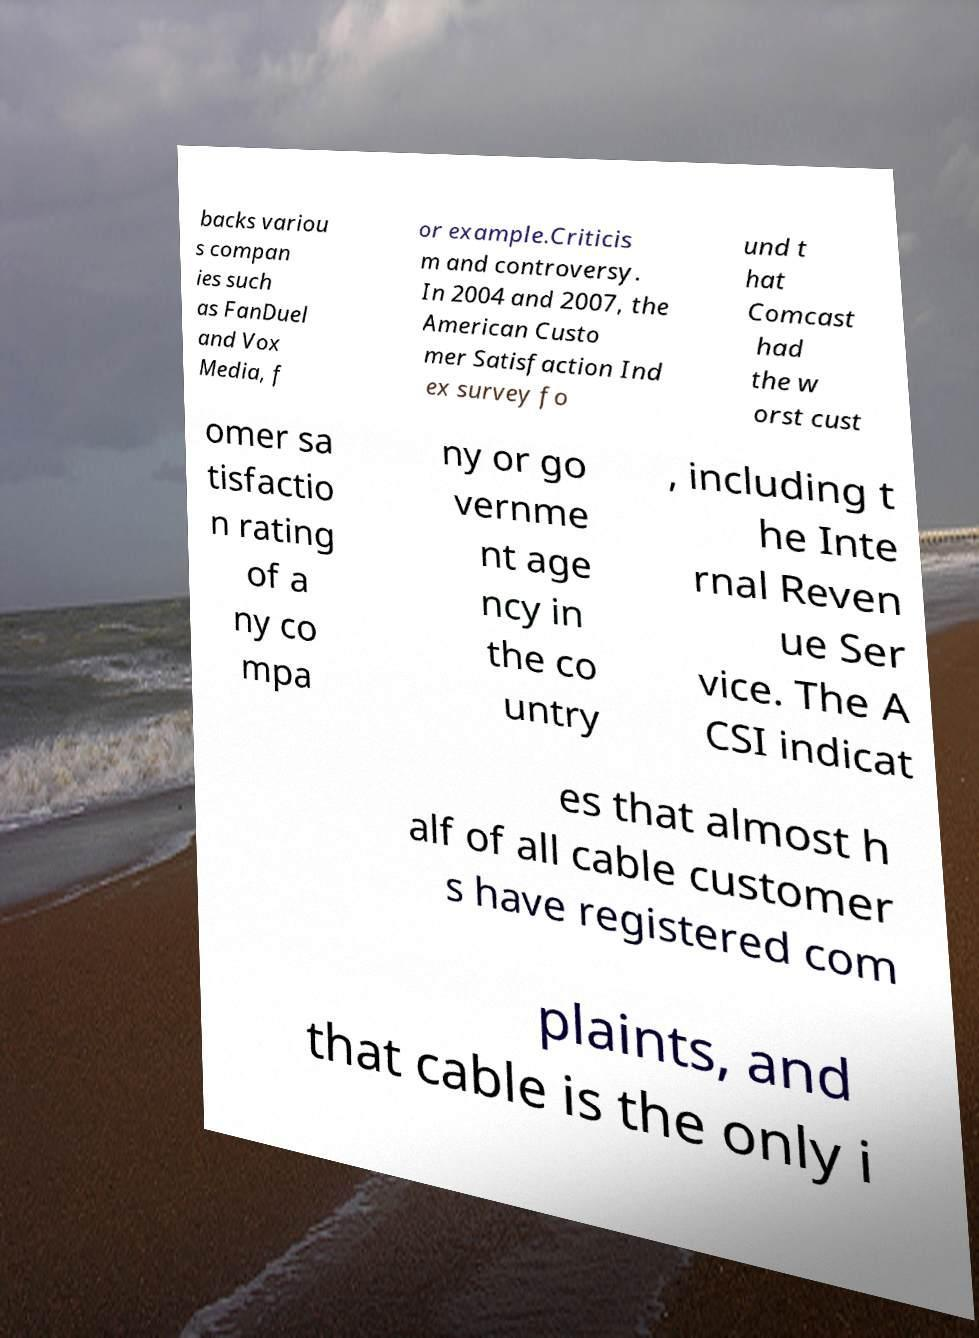Could you extract and type out the text from this image? backs variou s compan ies such as FanDuel and Vox Media, f or example.Criticis m and controversy. In 2004 and 2007, the American Custo mer Satisfaction Ind ex survey fo und t hat Comcast had the w orst cust omer sa tisfactio n rating of a ny co mpa ny or go vernme nt age ncy in the co untry , including t he Inte rnal Reven ue Ser vice. The A CSI indicat es that almost h alf of all cable customer s have registered com plaints, and that cable is the only i 